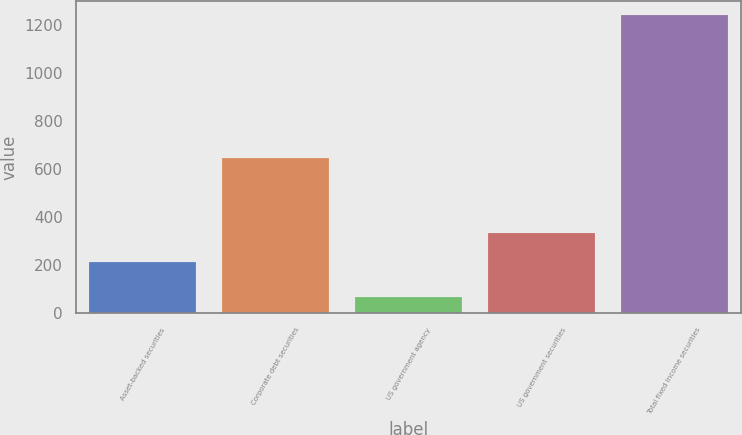Convert chart to OTSL. <chart><loc_0><loc_0><loc_500><loc_500><bar_chart><fcel>Asset-backed securities<fcel>Corporate debt securities<fcel>US government agency<fcel>US government securities<fcel>Total fixed income securities<nl><fcel>215.2<fcel>646.7<fcel>68.3<fcel>332.2<fcel>1238.3<nl></chart> 